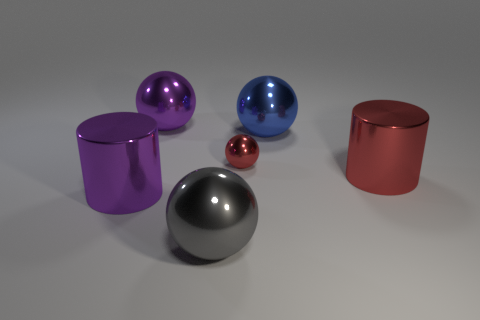Is the number of spheres behind the red cylinder greater than the number of gray objects?
Give a very brief answer. Yes. Are there fewer large objects that are in front of the large gray thing than purple cylinders?
Provide a short and direct response. Yes. How many other shiny things have the same color as the small thing?
Give a very brief answer. 1. What is the big object that is both in front of the small ball and on the right side of the tiny red sphere made of?
Ensure brevity in your answer.  Metal. There is a large metallic sphere left of the large gray object; does it have the same color as the cylinder on the left side of the big purple metal ball?
Your response must be concise. Yes. What number of blue things are large things or small metal spheres?
Your response must be concise. 1. Are there fewer large metal cylinders on the right side of the tiny red metal thing than large purple balls in front of the large gray metal thing?
Keep it short and to the point. No. Are there any purple balls that have the same size as the blue shiny object?
Make the answer very short. Yes. Is the size of the red metallic sphere right of the purple cylinder the same as the gray ball?
Offer a terse response. No. Is the number of spheres greater than the number of gray metal balls?
Your answer should be compact. Yes. 